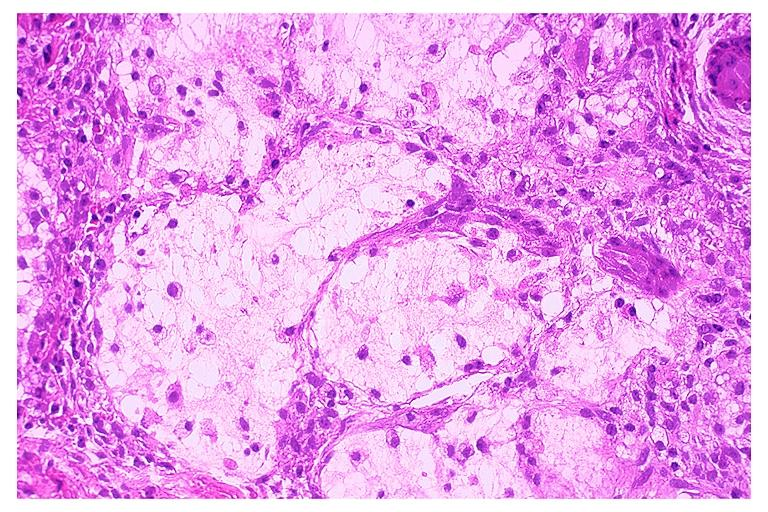does craniopharyngioma show necrotizing sialometaplasia?
Answer the question using a single word or phrase. No 